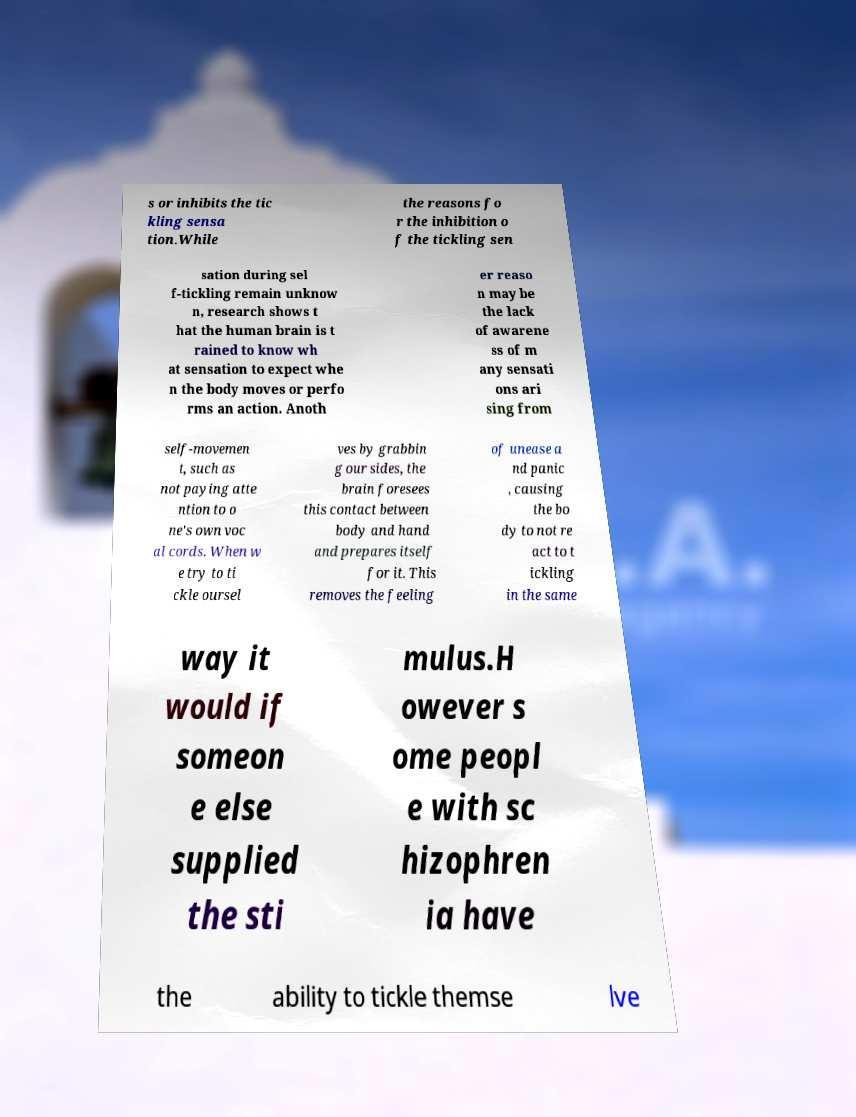Can you accurately transcribe the text from the provided image for me? s or inhibits the tic kling sensa tion.While the reasons fo r the inhibition o f the tickling sen sation during sel f-tickling remain unknow n, research shows t hat the human brain is t rained to know wh at sensation to expect whe n the body moves or perfo rms an action. Anoth er reaso n may be the lack of awarene ss of m any sensati ons ari sing from self-movemen t, such as not paying atte ntion to o ne's own voc al cords. When w e try to ti ckle oursel ves by grabbin g our sides, the brain foresees this contact between body and hand and prepares itself for it. This removes the feeling of unease a nd panic , causing the bo dy to not re act to t ickling in the same way it would if someon e else supplied the sti mulus.H owever s ome peopl e with sc hizophren ia have the ability to tickle themse lve 